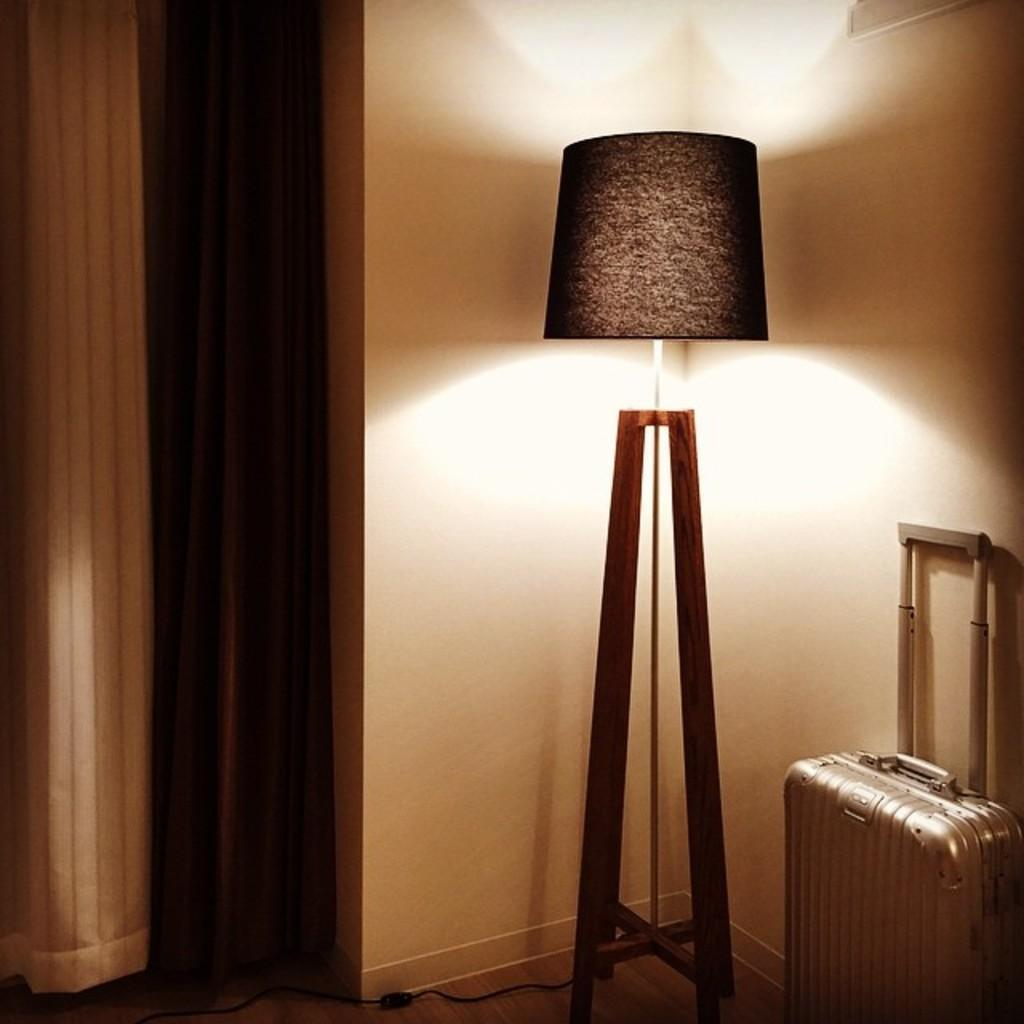What object can be seen in the image that is commonly used for carrying belongings? There is a suitcase in the image. What type of lighting is present in the image? There is a lamp on a stand in the image. What type of window treatment is visible in the image? There is a curtain in the image. What type of structure is visible in the background of the image? There is a wall in the image. How many girls are sitting on the cushion in the image? There are no girls or cushions present in the image. What type of reward is being given to the person in the image? There is no person or reward present in the image. 